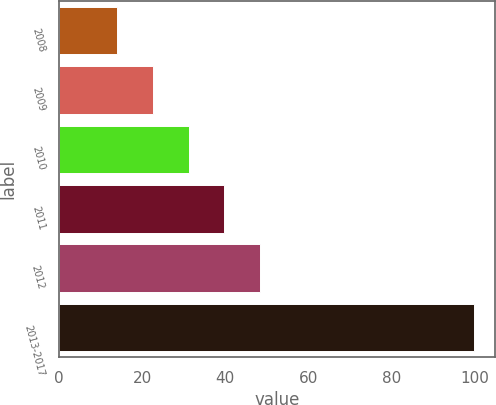Convert chart. <chart><loc_0><loc_0><loc_500><loc_500><bar_chart><fcel>2008<fcel>2009<fcel>2010<fcel>2011<fcel>2012<fcel>2013-2017<nl><fcel>14<fcel>22.6<fcel>31.2<fcel>39.8<fcel>48.4<fcel>100<nl></chart> 